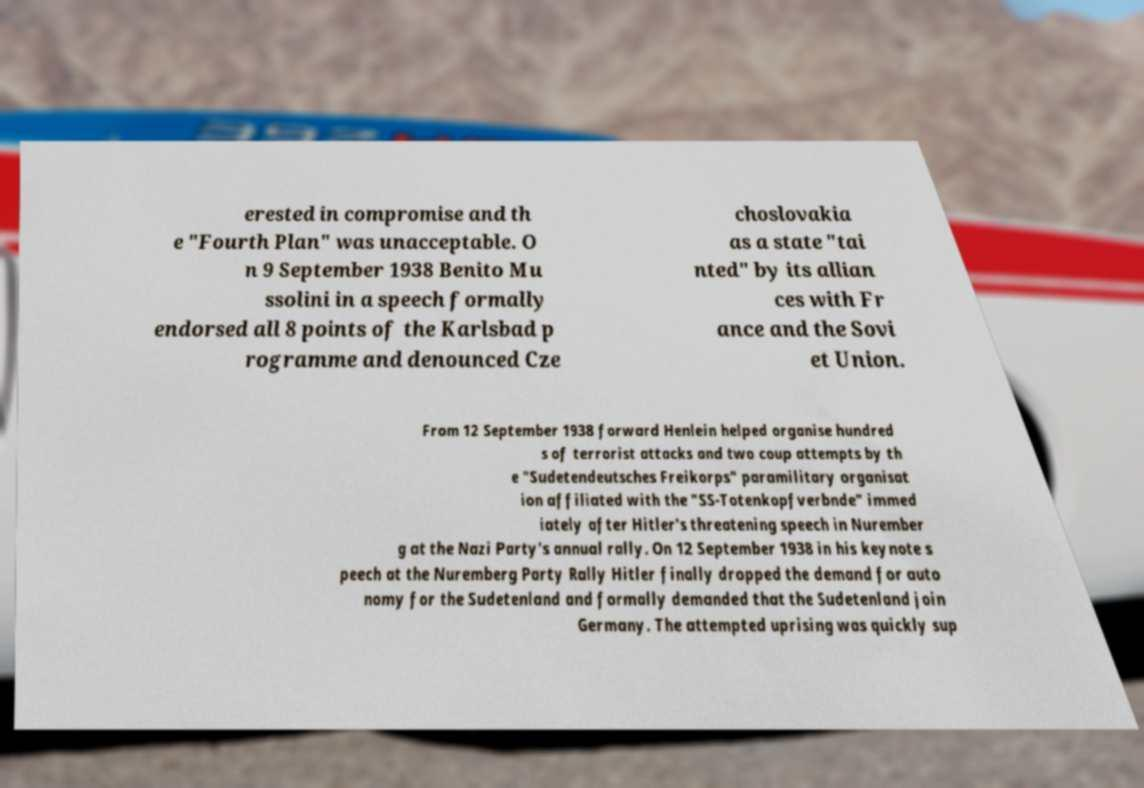Can you read and provide the text displayed in the image?This photo seems to have some interesting text. Can you extract and type it out for me? erested in compromise and th e "Fourth Plan" was unacceptable. O n 9 September 1938 Benito Mu ssolini in a speech formally endorsed all 8 points of the Karlsbad p rogramme and denounced Cze choslovakia as a state "tai nted" by its allian ces with Fr ance and the Sovi et Union. From 12 September 1938 forward Henlein helped organise hundred s of terrorist attacks and two coup attempts by th e "Sudetendeutsches Freikorps" paramilitary organisat ion affiliated with the "SS-Totenkopfverbnde" immed iately after Hitler's threatening speech in Nurember g at the Nazi Party's annual rally. On 12 September 1938 in his keynote s peech at the Nuremberg Party Rally Hitler finally dropped the demand for auto nomy for the Sudetenland and formally demanded that the Sudetenland join Germany. The attempted uprising was quickly sup 